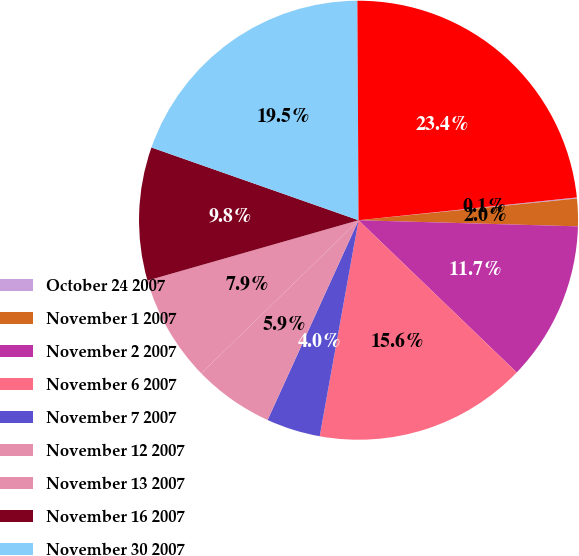Convert chart to OTSL. <chart><loc_0><loc_0><loc_500><loc_500><pie_chart><fcel>October 24 2007<fcel>November 1 2007<fcel>November 2 2007<fcel>November 6 2007<fcel>November 7 2007<fcel>November 12 2007<fcel>November 13 2007<fcel>November 16 2007<fcel>November 30 2007<fcel>December 11 2007<nl><fcel>0.08%<fcel>2.02%<fcel>11.75%<fcel>15.64%<fcel>3.97%<fcel>5.91%<fcel>7.86%<fcel>9.81%<fcel>19.54%<fcel>23.43%<nl></chart> 